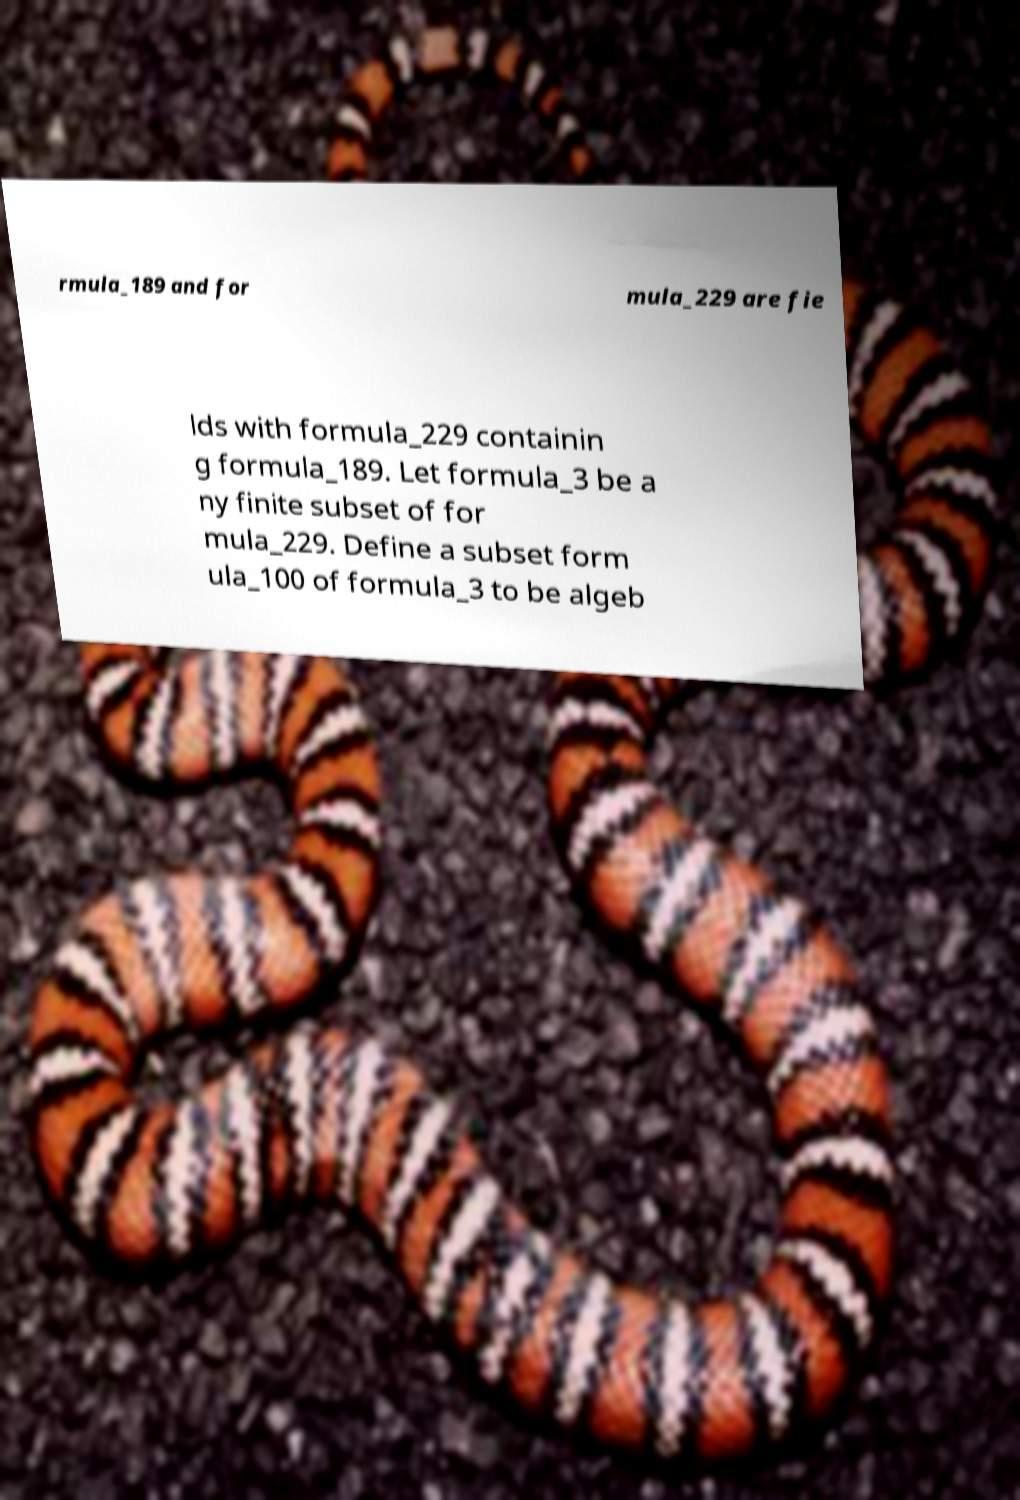What messages or text are displayed in this image? I need them in a readable, typed format. rmula_189 and for mula_229 are fie lds with formula_229 containin g formula_189. Let formula_3 be a ny finite subset of for mula_229. Define a subset form ula_100 of formula_3 to be algeb 